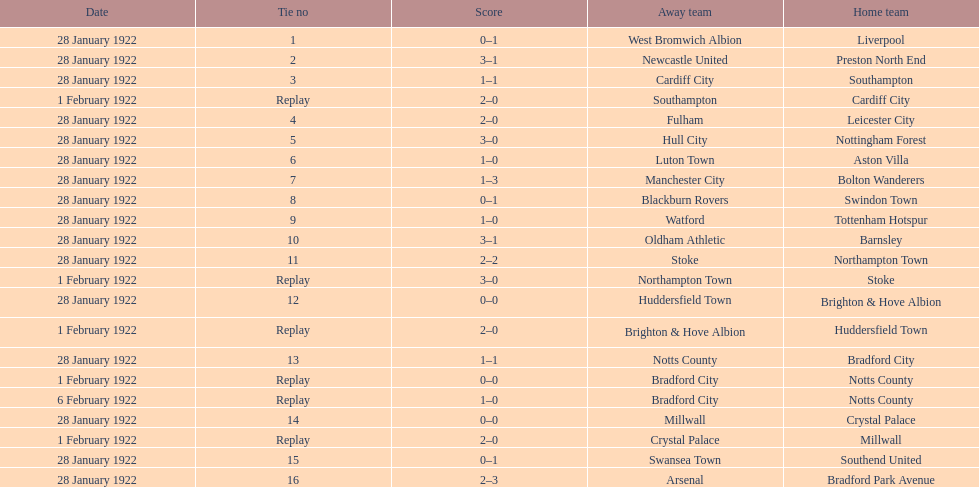How many games had no points scored? 3. 